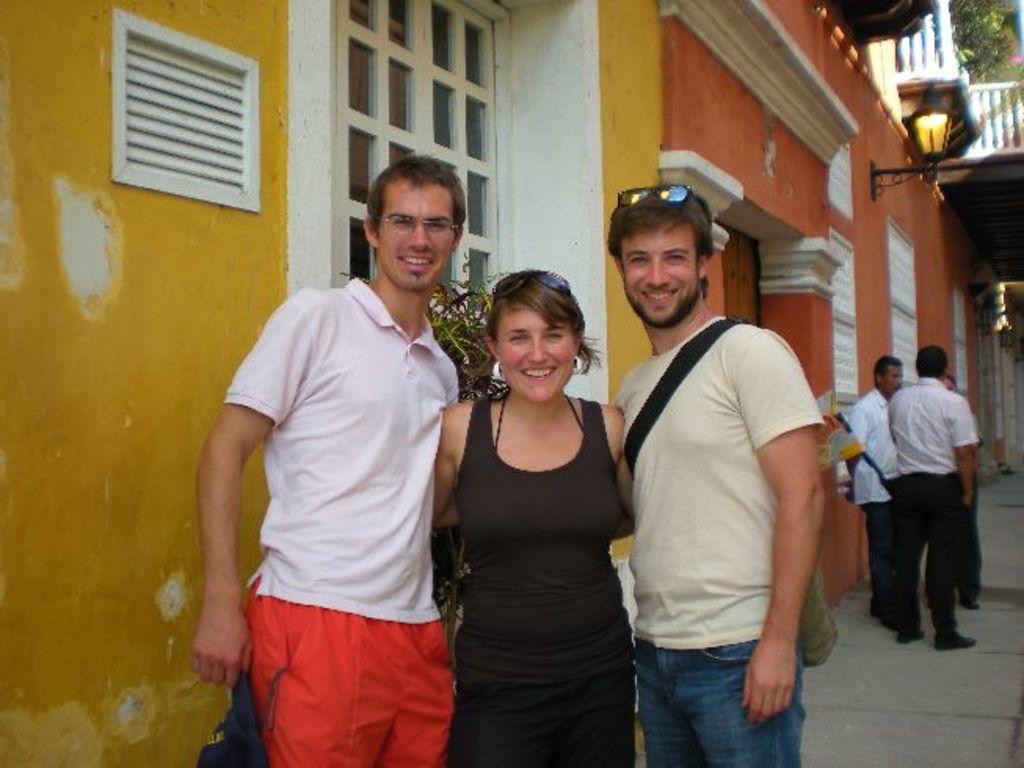How would you summarize this image in a sentence or two? In the image we can see two men and a woman standing, they are wearing clothes and they are smiling. This is a spectacle, cap and goggles. Behind them there are other people standing. This is a lamp, fence, plant, footpath, bag and a wall. 